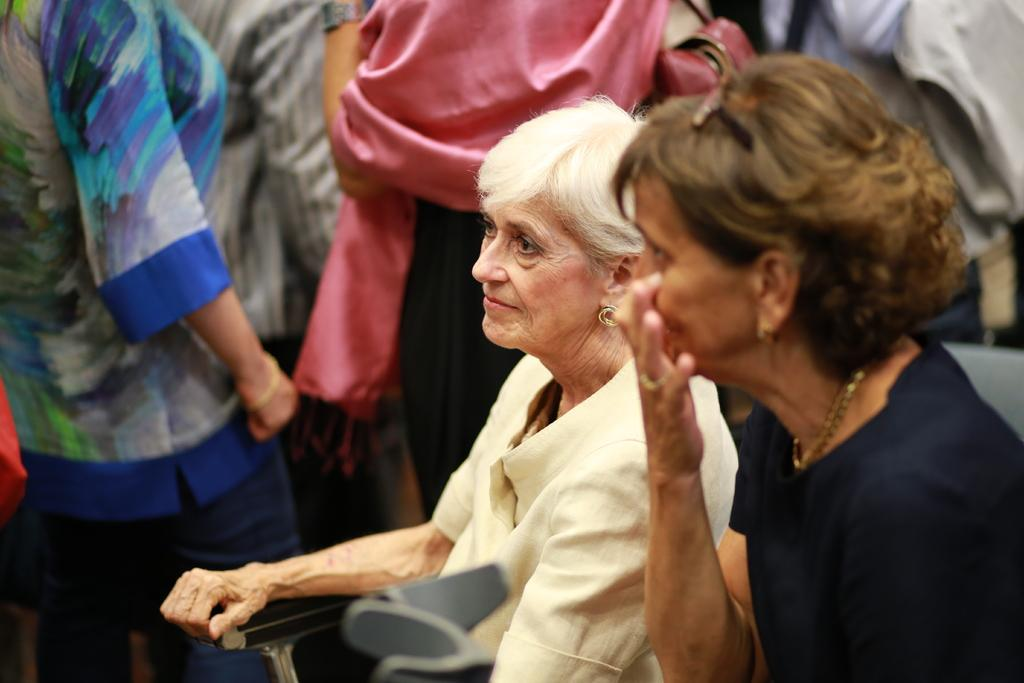What can be observed about the people in the image? There are people in the image, and some of them are standing. Are there any people sitting in the image? Yes, two people are sitting on chairs. What time of day is it in the image, and where are the ducks? The time of day is not mentioned in the image, and there are no ducks present. 